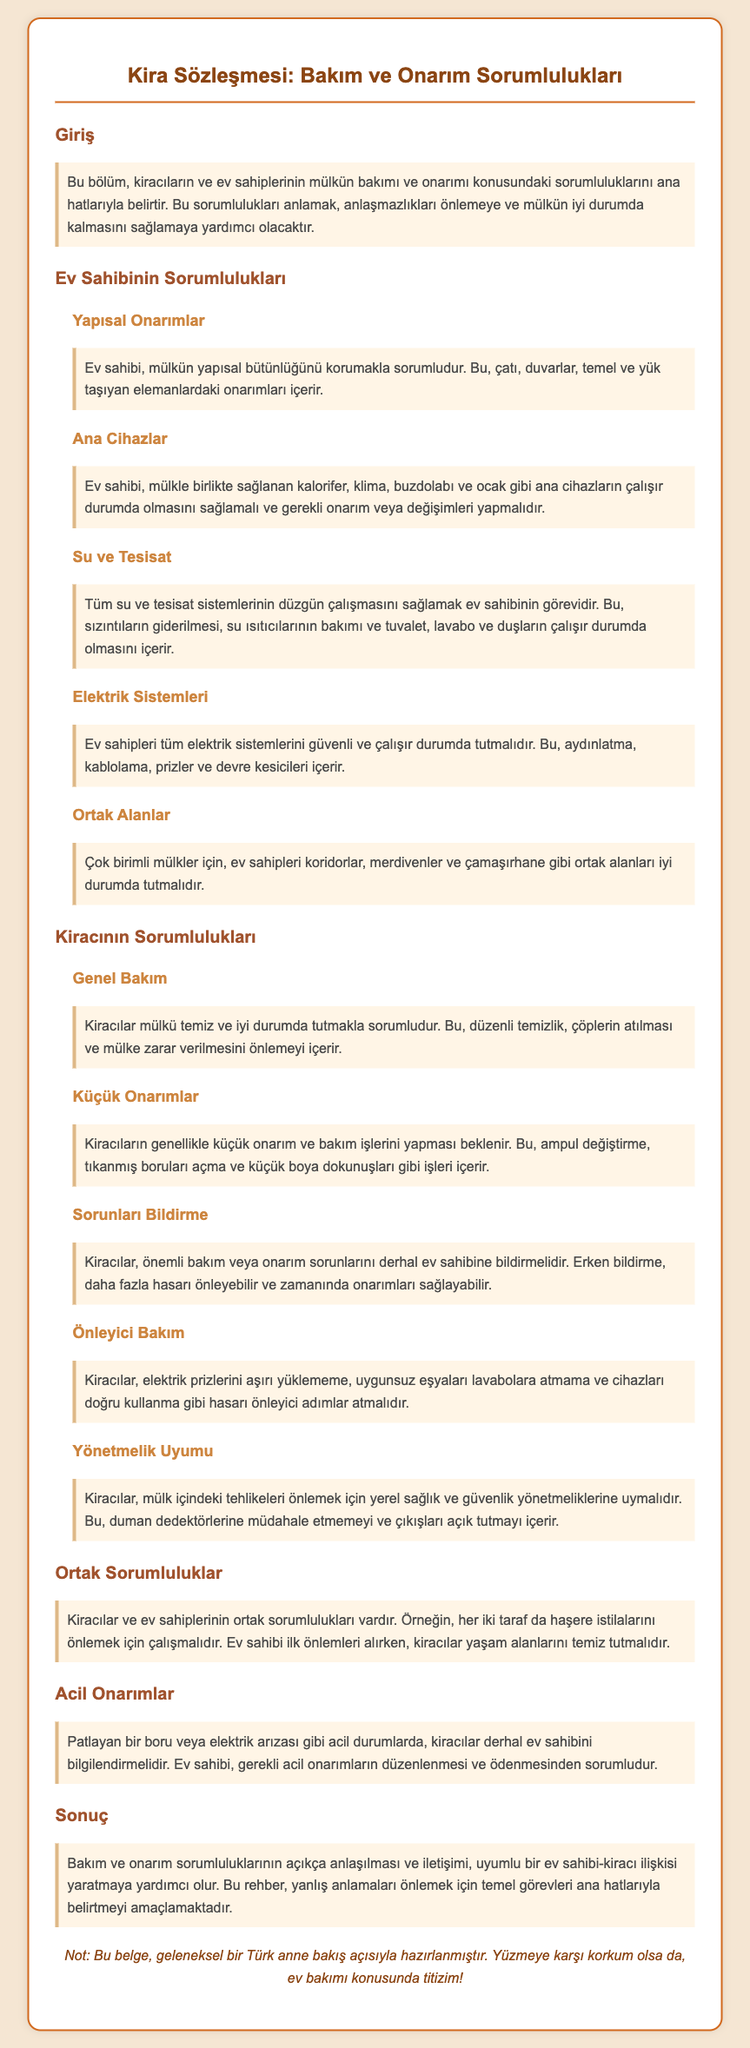what are the landlord's structural repair responsibilities? The landlord is responsible for maintaining the structural integrity of the property, including repairs to the roof, walls, foundation, and load-bearing elements.
Answer: structural repairs what major appliances must the landlord ensure are functioning? The landlord must ensure that the main appliances provided with the property, such as heating, air conditioning, refrigerator, and stove, are functional.
Answer: heating, air conditioning, refrigerator, stove what maintenance task is expected from tenants? Tenants are expected to keep the property clean and in good condition, which includes regular cleaning, proper disposal of garbage, and preventing damage to the property.
Answer: cleaning what actions should tenants take regarding minor repairs? Tenants are generally expected to perform minor repair and maintenance tasks, such as changing light bulbs, unclogging drains, and minor painting touch-ups.
Answer: minor repairs who is responsible for maintaining common areas in multi-unit properties? In multi-unit properties, the landlord is responsible for keeping common areas, such as hallways, staircases, and laundry areas, in good condition.
Answer: landlord when should tenants report major maintenance issues? Tenants should report significant maintenance or repair issues immediately to the landlord. Early reporting can prevent further damage and facilitate timely repairs.
Answer: immediately what is the shared responsibility related to pest infestations? Both tenants and landlords have shared responsibilities to prevent pest infestations; the landlord takes initial measures while tenants must keep living areas clean.
Answer: pest infestations what should tenants do in case of emergency repairs? In emergencies, such as a burst pipe or electrical failure, tenants must immediately inform the landlord, who is responsible for arranging and covering the necessary repairs.
Answer: inform the landlord what is a requirement for tenants regarding health and safety regulations? Tenants must comply with local health and safety regulations to prevent hazards within the property, such as not tampering with smoke detectors and keeping exits clear.
Answer: compliance with regulations 